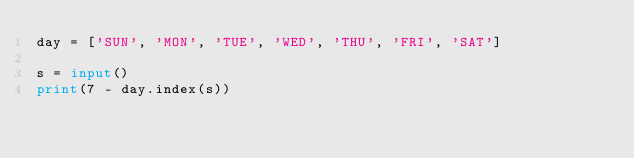<code> <loc_0><loc_0><loc_500><loc_500><_Python_>day = ['SUN', 'MON', 'TUE', 'WED', 'THU', 'FRI', 'SAT']

s = input()
print(7 - day.index(s))</code> 